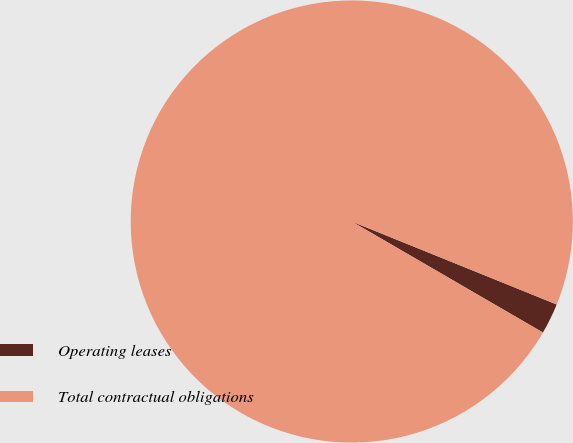<chart> <loc_0><loc_0><loc_500><loc_500><pie_chart><fcel>Operating leases<fcel>Total contractual obligations<nl><fcel>2.25%<fcel>97.75%<nl></chart> 